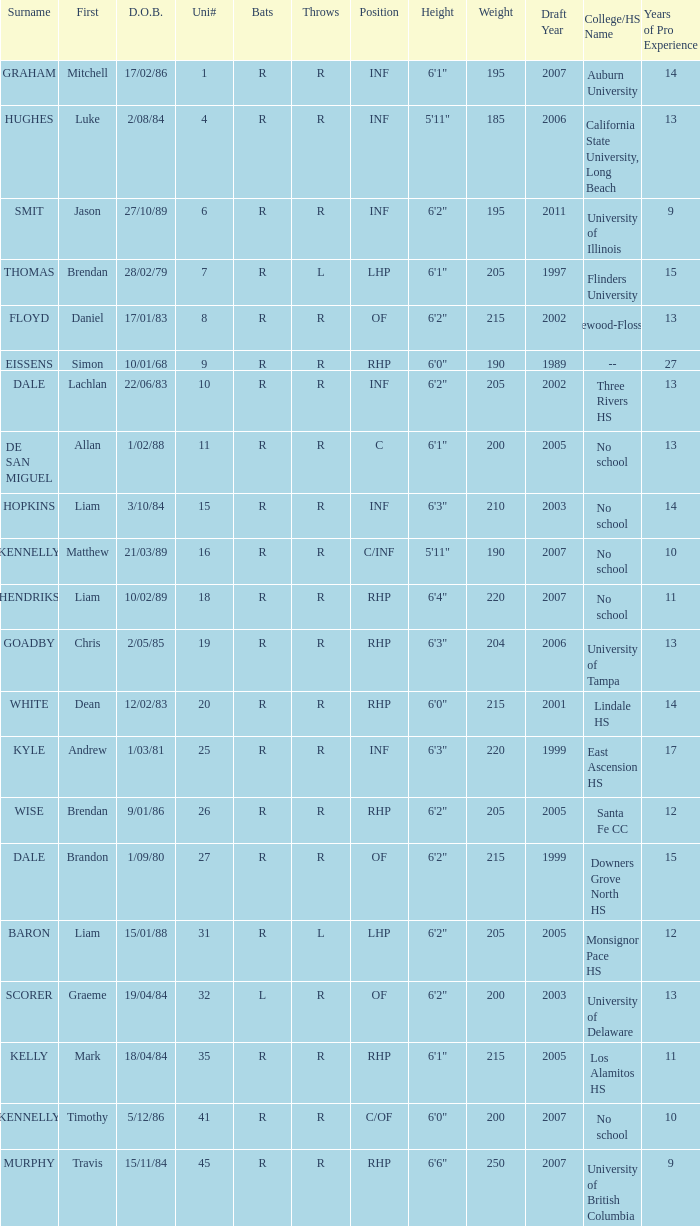Which hitter has the surname graham? R. 